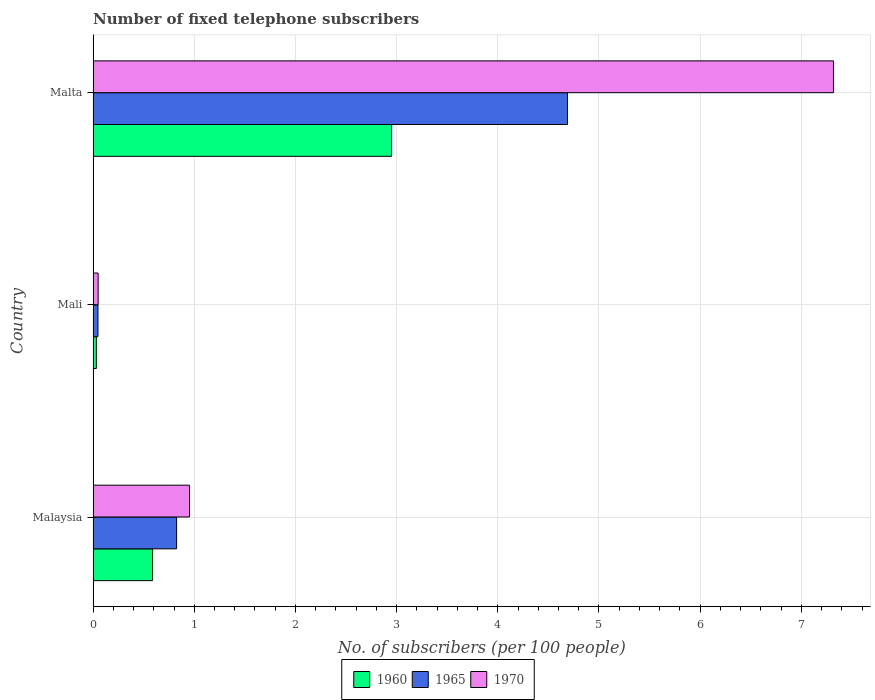How many groups of bars are there?
Your answer should be very brief. 3. Are the number of bars per tick equal to the number of legend labels?
Ensure brevity in your answer.  Yes. How many bars are there on the 3rd tick from the top?
Provide a succinct answer. 3. How many bars are there on the 1st tick from the bottom?
Your response must be concise. 3. What is the label of the 3rd group of bars from the top?
Offer a very short reply. Malaysia. In how many cases, is the number of bars for a given country not equal to the number of legend labels?
Your answer should be very brief. 0. What is the number of fixed telephone subscribers in 1960 in Malta?
Provide a succinct answer. 2.95. Across all countries, what is the maximum number of fixed telephone subscribers in 1970?
Provide a succinct answer. 7.32. Across all countries, what is the minimum number of fixed telephone subscribers in 1960?
Give a very brief answer. 0.03. In which country was the number of fixed telephone subscribers in 1970 maximum?
Your response must be concise. Malta. In which country was the number of fixed telephone subscribers in 1965 minimum?
Make the answer very short. Mali. What is the total number of fixed telephone subscribers in 1960 in the graph?
Make the answer very short. 3.57. What is the difference between the number of fixed telephone subscribers in 1970 in Malaysia and that in Malta?
Offer a terse response. -6.36. What is the difference between the number of fixed telephone subscribers in 1970 in Malaysia and the number of fixed telephone subscribers in 1960 in Malta?
Make the answer very short. -2. What is the average number of fixed telephone subscribers in 1965 per country?
Offer a terse response. 1.85. What is the difference between the number of fixed telephone subscribers in 1965 and number of fixed telephone subscribers in 1970 in Malaysia?
Make the answer very short. -0.13. In how many countries, is the number of fixed telephone subscribers in 1970 greater than 3.6 ?
Make the answer very short. 1. What is the ratio of the number of fixed telephone subscribers in 1970 in Malaysia to that in Malta?
Your answer should be very brief. 0.13. What is the difference between the highest and the second highest number of fixed telephone subscribers in 1965?
Your answer should be very brief. 3.86. What is the difference between the highest and the lowest number of fixed telephone subscribers in 1960?
Your answer should be very brief. 2.92. Is the sum of the number of fixed telephone subscribers in 1960 in Malaysia and Malta greater than the maximum number of fixed telephone subscribers in 1970 across all countries?
Give a very brief answer. No. What does the 1st bar from the bottom in Malta represents?
Provide a short and direct response. 1960. Is it the case that in every country, the sum of the number of fixed telephone subscribers in 1970 and number of fixed telephone subscribers in 1965 is greater than the number of fixed telephone subscribers in 1960?
Make the answer very short. Yes. How many bars are there?
Offer a very short reply. 9. What is the difference between two consecutive major ticks on the X-axis?
Your answer should be very brief. 1. Are the values on the major ticks of X-axis written in scientific E-notation?
Give a very brief answer. No. Does the graph contain grids?
Provide a short and direct response. Yes. Where does the legend appear in the graph?
Offer a very short reply. Bottom center. What is the title of the graph?
Your response must be concise. Number of fixed telephone subscribers. Does "1970" appear as one of the legend labels in the graph?
Offer a very short reply. Yes. What is the label or title of the X-axis?
Provide a succinct answer. No. of subscribers (per 100 people). What is the No. of subscribers (per 100 people) in 1960 in Malaysia?
Your answer should be very brief. 0.59. What is the No. of subscribers (per 100 people) of 1965 in Malaysia?
Offer a terse response. 0.83. What is the No. of subscribers (per 100 people) in 1970 in Malaysia?
Give a very brief answer. 0.95. What is the No. of subscribers (per 100 people) of 1960 in Mali?
Keep it short and to the point. 0.03. What is the No. of subscribers (per 100 people) in 1965 in Mali?
Offer a very short reply. 0.05. What is the No. of subscribers (per 100 people) in 1970 in Mali?
Make the answer very short. 0.05. What is the No. of subscribers (per 100 people) of 1960 in Malta?
Give a very brief answer. 2.95. What is the No. of subscribers (per 100 people) of 1965 in Malta?
Your answer should be very brief. 4.69. What is the No. of subscribers (per 100 people) in 1970 in Malta?
Ensure brevity in your answer.  7.32. Across all countries, what is the maximum No. of subscribers (per 100 people) of 1960?
Ensure brevity in your answer.  2.95. Across all countries, what is the maximum No. of subscribers (per 100 people) of 1965?
Keep it short and to the point. 4.69. Across all countries, what is the maximum No. of subscribers (per 100 people) in 1970?
Offer a terse response. 7.32. Across all countries, what is the minimum No. of subscribers (per 100 people) of 1960?
Provide a succinct answer. 0.03. Across all countries, what is the minimum No. of subscribers (per 100 people) of 1965?
Give a very brief answer. 0.05. Across all countries, what is the minimum No. of subscribers (per 100 people) in 1970?
Provide a succinct answer. 0.05. What is the total No. of subscribers (per 100 people) in 1960 in the graph?
Your answer should be very brief. 3.57. What is the total No. of subscribers (per 100 people) of 1965 in the graph?
Keep it short and to the point. 5.56. What is the total No. of subscribers (per 100 people) of 1970 in the graph?
Keep it short and to the point. 8.32. What is the difference between the No. of subscribers (per 100 people) in 1960 in Malaysia and that in Mali?
Give a very brief answer. 0.56. What is the difference between the No. of subscribers (per 100 people) of 1965 in Malaysia and that in Mali?
Your answer should be very brief. 0.78. What is the difference between the No. of subscribers (per 100 people) of 1970 in Malaysia and that in Mali?
Your answer should be very brief. 0.9. What is the difference between the No. of subscribers (per 100 people) of 1960 in Malaysia and that in Malta?
Provide a short and direct response. -2.36. What is the difference between the No. of subscribers (per 100 people) of 1965 in Malaysia and that in Malta?
Offer a terse response. -3.86. What is the difference between the No. of subscribers (per 100 people) of 1970 in Malaysia and that in Malta?
Offer a terse response. -6.36. What is the difference between the No. of subscribers (per 100 people) in 1960 in Mali and that in Malta?
Provide a succinct answer. -2.92. What is the difference between the No. of subscribers (per 100 people) in 1965 in Mali and that in Malta?
Make the answer very short. -4.64. What is the difference between the No. of subscribers (per 100 people) in 1970 in Mali and that in Malta?
Ensure brevity in your answer.  -7.27. What is the difference between the No. of subscribers (per 100 people) of 1960 in Malaysia and the No. of subscribers (per 100 people) of 1965 in Mali?
Provide a short and direct response. 0.54. What is the difference between the No. of subscribers (per 100 people) in 1960 in Malaysia and the No. of subscribers (per 100 people) in 1970 in Mali?
Provide a succinct answer. 0.54. What is the difference between the No. of subscribers (per 100 people) in 1965 in Malaysia and the No. of subscribers (per 100 people) in 1970 in Mali?
Make the answer very short. 0.78. What is the difference between the No. of subscribers (per 100 people) of 1960 in Malaysia and the No. of subscribers (per 100 people) of 1965 in Malta?
Your answer should be very brief. -4.1. What is the difference between the No. of subscribers (per 100 people) in 1960 in Malaysia and the No. of subscribers (per 100 people) in 1970 in Malta?
Provide a succinct answer. -6.73. What is the difference between the No. of subscribers (per 100 people) in 1965 in Malaysia and the No. of subscribers (per 100 people) in 1970 in Malta?
Your answer should be compact. -6.49. What is the difference between the No. of subscribers (per 100 people) in 1960 in Mali and the No. of subscribers (per 100 people) in 1965 in Malta?
Make the answer very short. -4.66. What is the difference between the No. of subscribers (per 100 people) of 1960 in Mali and the No. of subscribers (per 100 people) of 1970 in Malta?
Offer a very short reply. -7.29. What is the difference between the No. of subscribers (per 100 people) in 1965 in Mali and the No. of subscribers (per 100 people) in 1970 in Malta?
Offer a terse response. -7.27. What is the average No. of subscribers (per 100 people) in 1960 per country?
Keep it short and to the point. 1.19. What is the average No. of subscribers (per 100 people) of 1965 per country?
Give a very brief answer. 1.85. What is the average No. of subscribers (per 100 people) of 1970 per country?
Give a very brief answer. 2.77. What is the difference between the No. of subscribers (per 100 people) in 1960 and No. of subscribers (per 100 people) in 1965 in Malaysia?
Your answer should be compact. -0.24. What is the difference between the No. of subscribers (per 100 people) in 1960 and No. of subscribers (per 100 people) in 1970 in Malaysia?
Offer a very short reply. -0.36. What is the difference between the No. of subscribers (per 100 people) of 1965 and No. of subscribers (per 100 people) of 1970 in Malaysia?
Ensure brevity in your answer.  -0.13. What is the difference between the No. of subscribers (per 100 people) in 1960 and No. of subscribers (per 100 people) in 1965 in Mali?
Your response must be concise. -0.02. What is the difference between the No. of subscribers (per 100 people) in 1960 and No. of subscribers (per 100 people) in 1970 in Mali?
Provide a succinct answer. -0.02. What is the difference between the No. of subscribers (per 100 people) of 1965 and No. of subscribers (per 100 people) of 1970 in Mali?
Ensure brevity in your answer.  -0. What is the difference between the No. of subscribers (per 100 people) of 1960 and No. of subscribers (per 100 people) of 1965 in Malta?
Your answer should be compact. -1.74. What is the difference between the No. of subscribers (per 100 people) of 1960 and No. of subscribers (per 100 people) of 1970 in Malta?
Provide a succinct answer. -4.37. What is the difference between the No. of subscribers (per 100 people) of 1965 and No. of subscribers (per 100 people) of 1970 in Malta?
Your response must be concise. -2.63. What is the ratio of the No. of subscribers (per 100 people) in 1960 in Malaysia to that in Mali?
Ensure brevity in your answer.  18.21. What is the ratio of the No. of subscribers (per 100 people) of 1965 in Malaysia to that in Mali?
Your response must be concise. 17.06. What is the ratio of the No. of subscribers (per 100 people) of 1970 in Malaysia to that in Mali?
Ensure brevity in your answer.  19.1. What is the ratio of the No. of subscribers (per 100 people) of 1960 in Malaysia to that in Malta?
Provide a succinct answer. 0.2. What is the ratio of the No. of subscribers (per 100 people) in 1965 in Malaysia to that in Malta?
Your response must be concise. 0.18. What is the ratio of the No. of subscribers (per 100 people) of 1970 in Malaysia to that in Malta?
Provide a succinct answer. 0.13. What is the ratio of the No. of subscribers (per 100 people) of 1960 in Mali to that in Malta?
Your answer should be very brief. 0.01. What is the ratio of the No. of subscribers (per 100 people) of 1965 in Mali to that in Malta?
Keep it short and to the point. 0.01. What is the ratio of the No. of subscribers (per 100 people) in 1970 in Mali to that in Malta?
Ensure brevity in your answer.  0.01. What is the difference between the highest and the second highest No. of subscribers (per 100 people) of 1960?
Your answer should be compact. 2.36. What is the difference between the highest and the second highest No. of subscribers (per 100 people) of 1965?
Offer a very short reply. 3.86. What is the difference between the highest and the second highest No. of subscribers (per 100 people) of 1970?
Give a very brief answer. 6.36. What is the difference between the highest and the lowest No. of subscribers (per 100 people) of 1960?
Provide a short and direct response. 2.92. What is the difference between the highest and the lowest No. of subscribers (per 100 people) in 1965?
Give a very brief answer. 4.64. What is the difference between the highest and the lowest No. of subscribers (per 100 people) in 1970?
Keep it short and to the point. 7.27. 